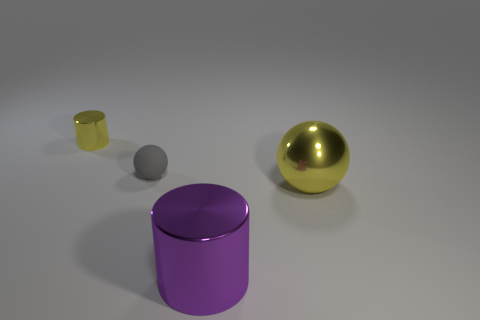What number of other big yellow metal things are the same shape as the large yellow object?
Ensure brevity in your answer.  0. What number of gray metal things are there?
Your response must be concise. 0. There is a metal thing that is both behind the purple cylinder and in front of the matte object; what is its size?
Your response must be concise. Large. What is the shape of the purple object that is the same size as the yellow shiny ball?
Ensure brevity in your answer.  Cylinder. There is a yellow shiny thing to the left of the small gray sphere; is there a small metallic thing that is behind it?
Provide a succinct answer. No. What color is the large shiny object that is the same shape as the tiny yellow metallic object?
Give a very brief answer. Purple. Does the cylinder behind the gray matte object have the same color as the small matte object?
Give a very brief answer. No. What number of objects are either tiny things that are to the left of the rubber ball or large metallic things?
Give a very brief answer. 3. The cylinder that is behind the shiny thing that is in front of the yellow thing right of the yellow metal cylinder is made of what material?
Provide a succinct answer. Metal. Are there more gray rubber balls that are behind the tiny yellow metallic cylinder than rubber balls that are behind the gray rubber object?
Offer a very short reply. No. 